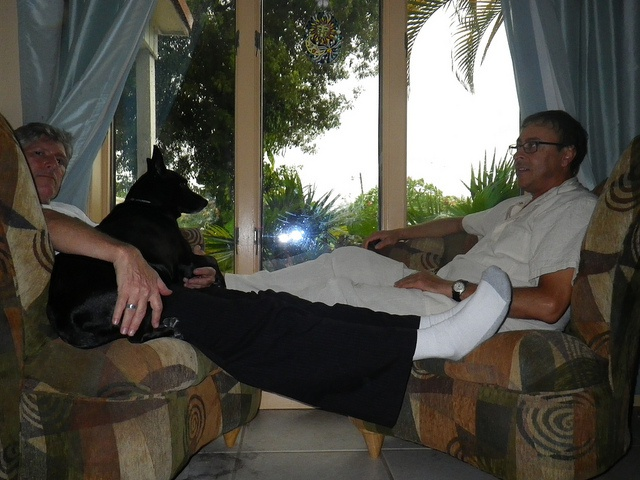Describe the objects in this image and their specific colors. I can see couch in gray, black, and maroon tones, couch in gray and black tones, people in gray, black, darkgray, and maroon tones, people in gray, black, and maroon tones, and dog in gray and black tones in this image. 